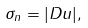<formula> <loc_0><loc_0><loc_500><loc_500>\sigma _ { n } = | D u | ,</formula> 